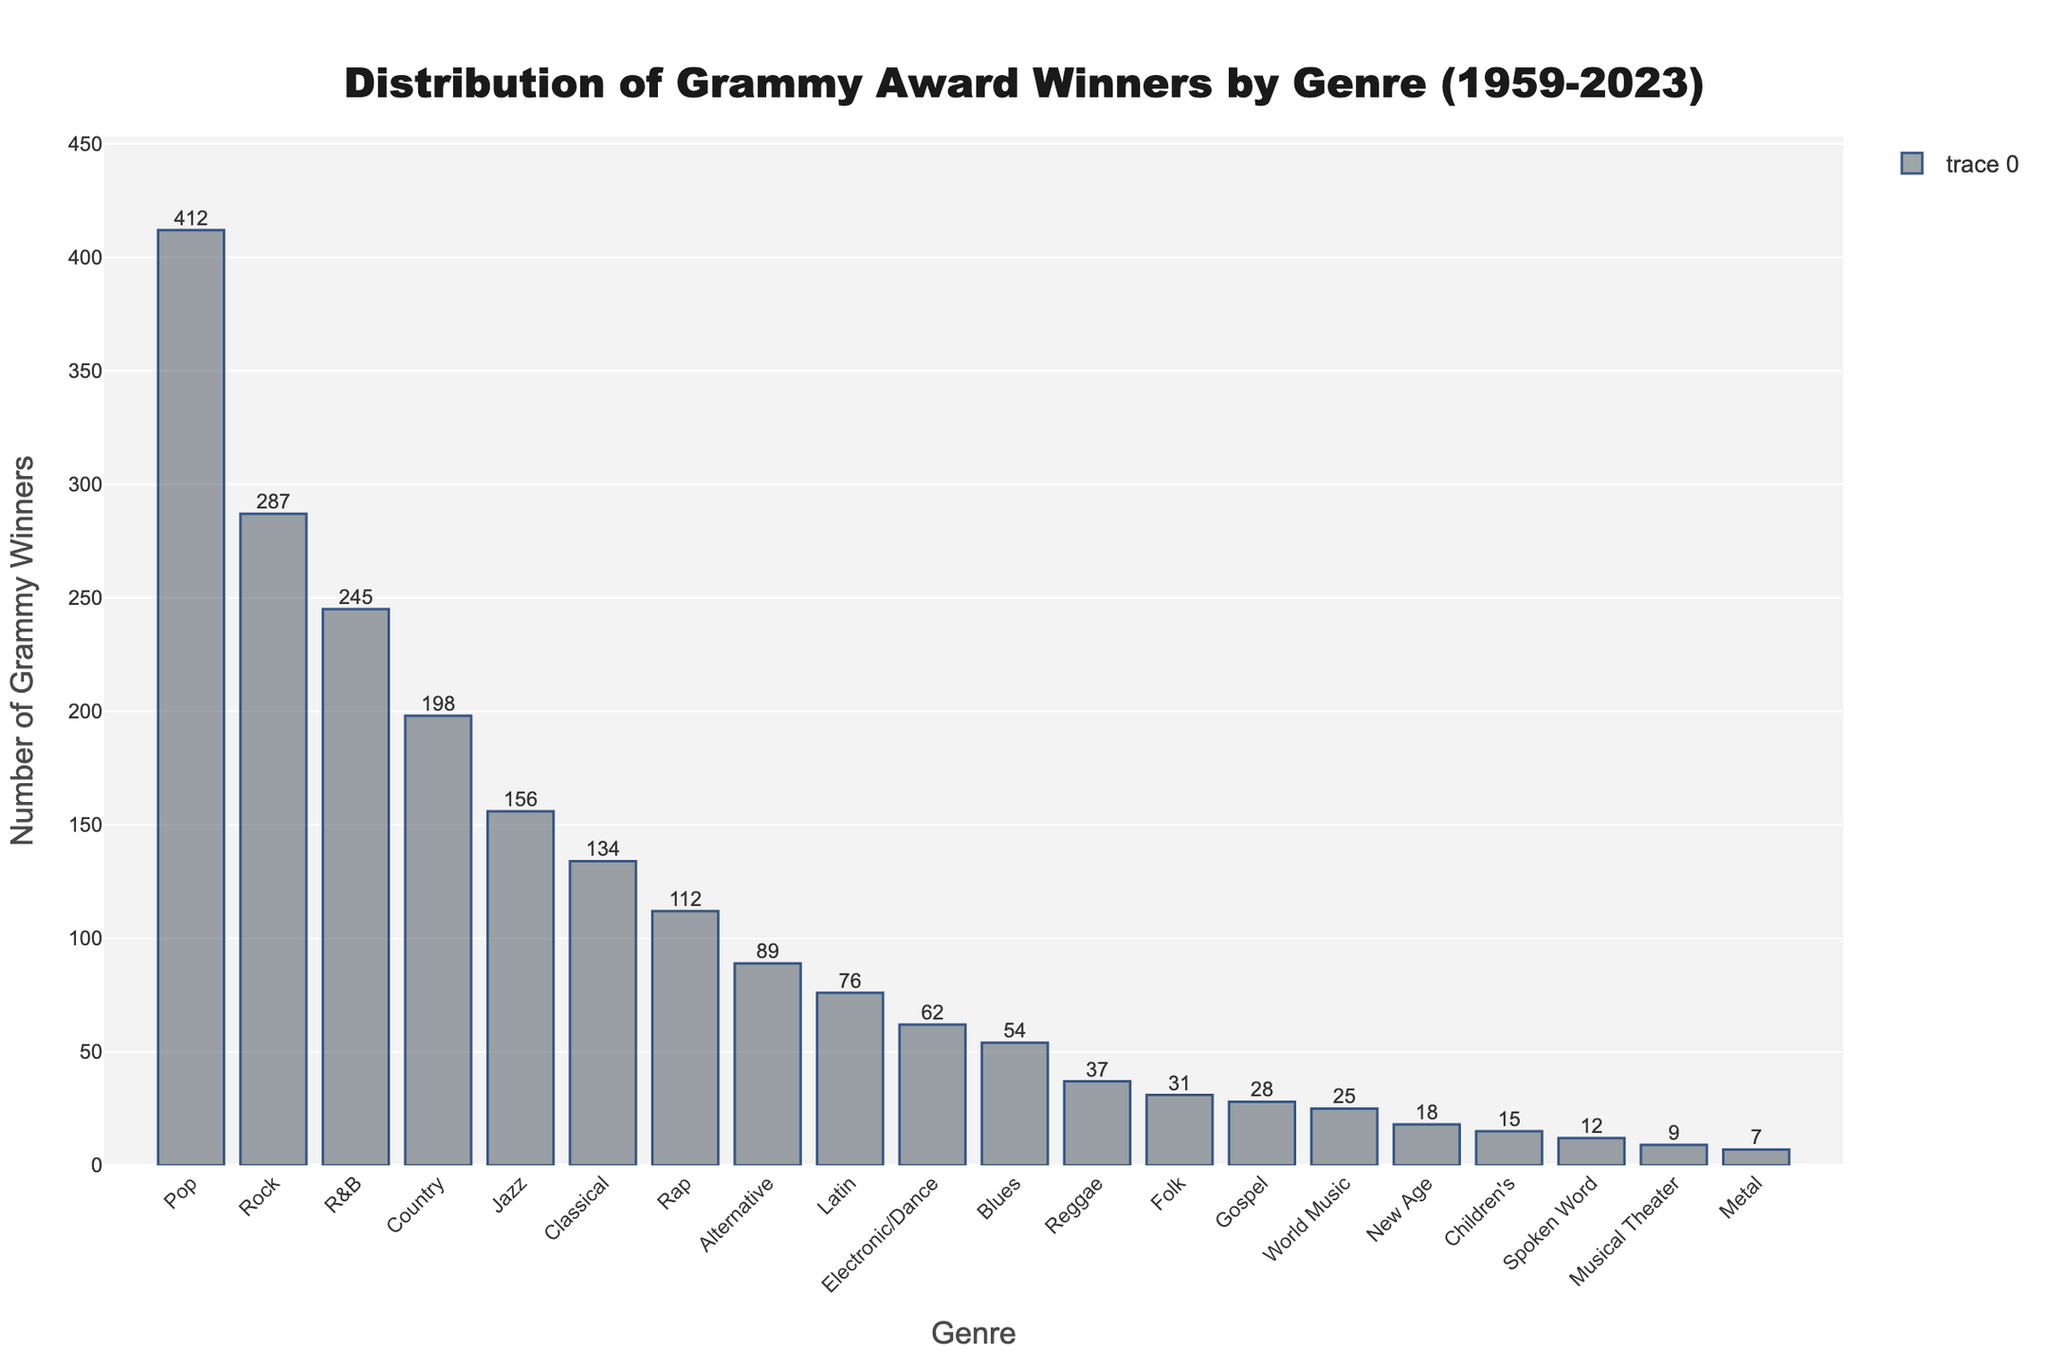What genre has the highest number of Grammy winners? The highest bar in the chart represents the genre with the most Grammy winners. The "Pop" genre has the tallest bar.
Answer: Pop How many more Grammy winners does Pop have compared to Rock? Subtract the number of Rock Grammy winners from the number of Pop Grammy winners: 412 - 287 = 125
Answer: 125 What's the total number of Grammy winners in Jazz, Classical, and Blues genres combined? Add the numbers of Grammy winners for Jazz (156), Classical (134), and Blues (54): 156 + 134 + 54 = 344
Answer: 344 Which genre has fewer Grammy winners: Latin or Electronic/Dance? Compare the heights of the bars representing Latin and Electronic/Dance. The Latin bar is slightly taller than the Electronic/Dance bar.
Answer: Electronic/Dance Does the R&B genre have more Grammy winners than Country? Compare the heights of the bars for R&B and Country. The R&B bar is taller.
Answer: Yes What's the combined number of Grammy winners in Rap and Alternative genres? Add the number of Grammy winners for Rap (112) and Alternative (89): 112 + 89 = 201
Answer: 201 Which genre has the smallest number of Grammy winners? Find the bar with the smallest height. The "Metal" genre has the shortest bar.
Answer: Metal How many genres have more than 200 Grammy winners? Count the number of bars with a height greater than the 200 mark: Pop, Rock, and R&B.
Answer: 3 Compare the number of Grammy winners in Children's and Spoken Word genres; which has more, and by how much? Subtract the number of Spoken Word Grammy winners (12) from the number of Children's Grammy winners (15): 15 - 12 = 3. Children's has more winners.
Answer: Children's by 3 What is the difference in the number of Grammy winners between Jazz and Rap genres? Subtract the number of Rap Grammy winners (112) from the number of Jazz Grammy winners (156): 156 - 112 = 44.
Answer: 44 